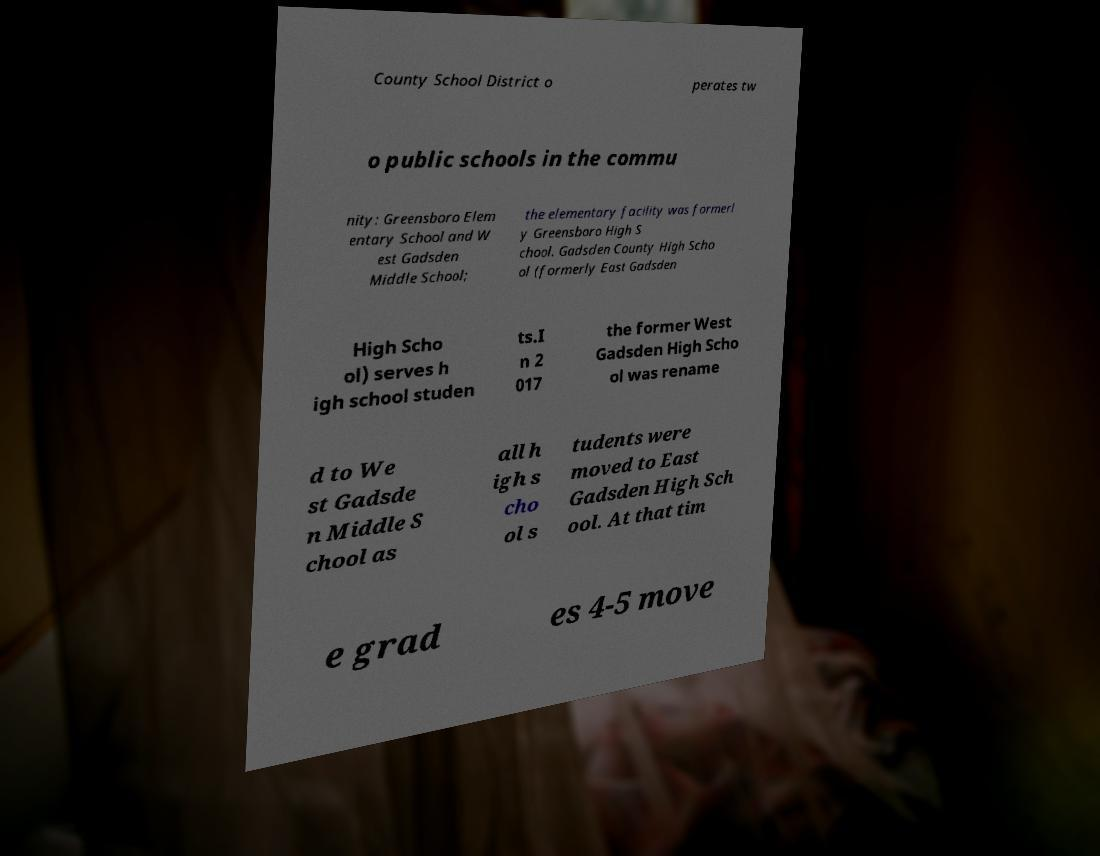There's text embedded in this image that I need extracted. Can you transcribe it verbatim? County School District o perates tw o public schools in the commu nity: Greensboro Elem entary School and W est Gadsden Middle School; the elementary facility was formerl y Greensboro High S chool. Gadsden County High Scho ol (formerly East Gadsden High Scho ol) serves h igh school studen ts.I n 2 017 the former West Gadsden High Scho ol was rename d to We st Gadsde n Middle S chool as all h igh s cho ol s tudents were moved to East Gadsden High Sch ool. At that tim e grad es 4-5 move 